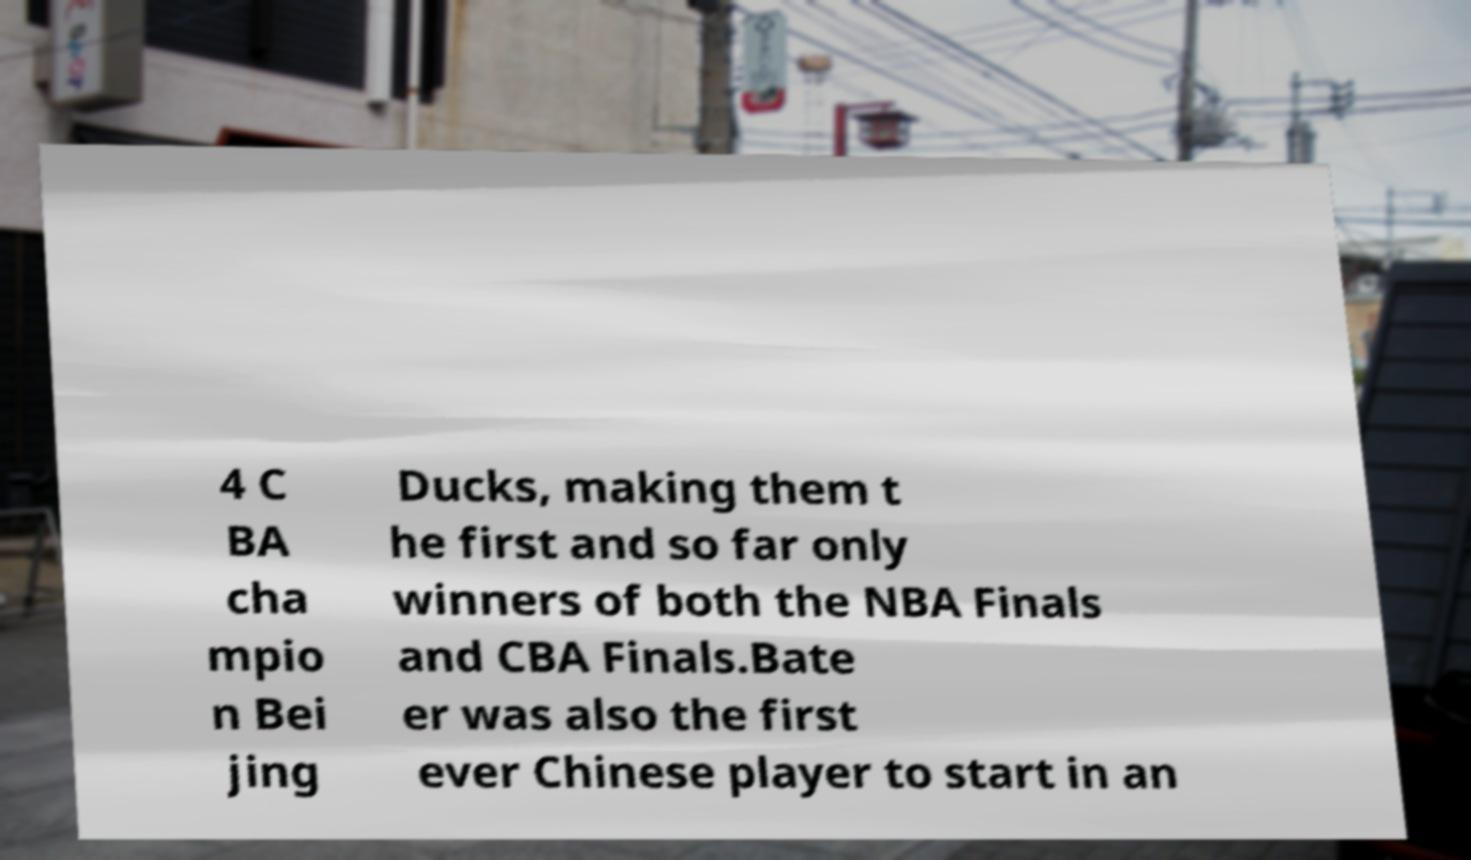Can you read and provide the text displayed in the image?This photo seems to have some interesting text. Can you extract and type it out for me? 4 C BA cha mpio n Bei jing Ducks, making them t he first and so far only winners of both the NBA Finals and CBA Finals.Bate er was also the first ever Chinese player to start in an 